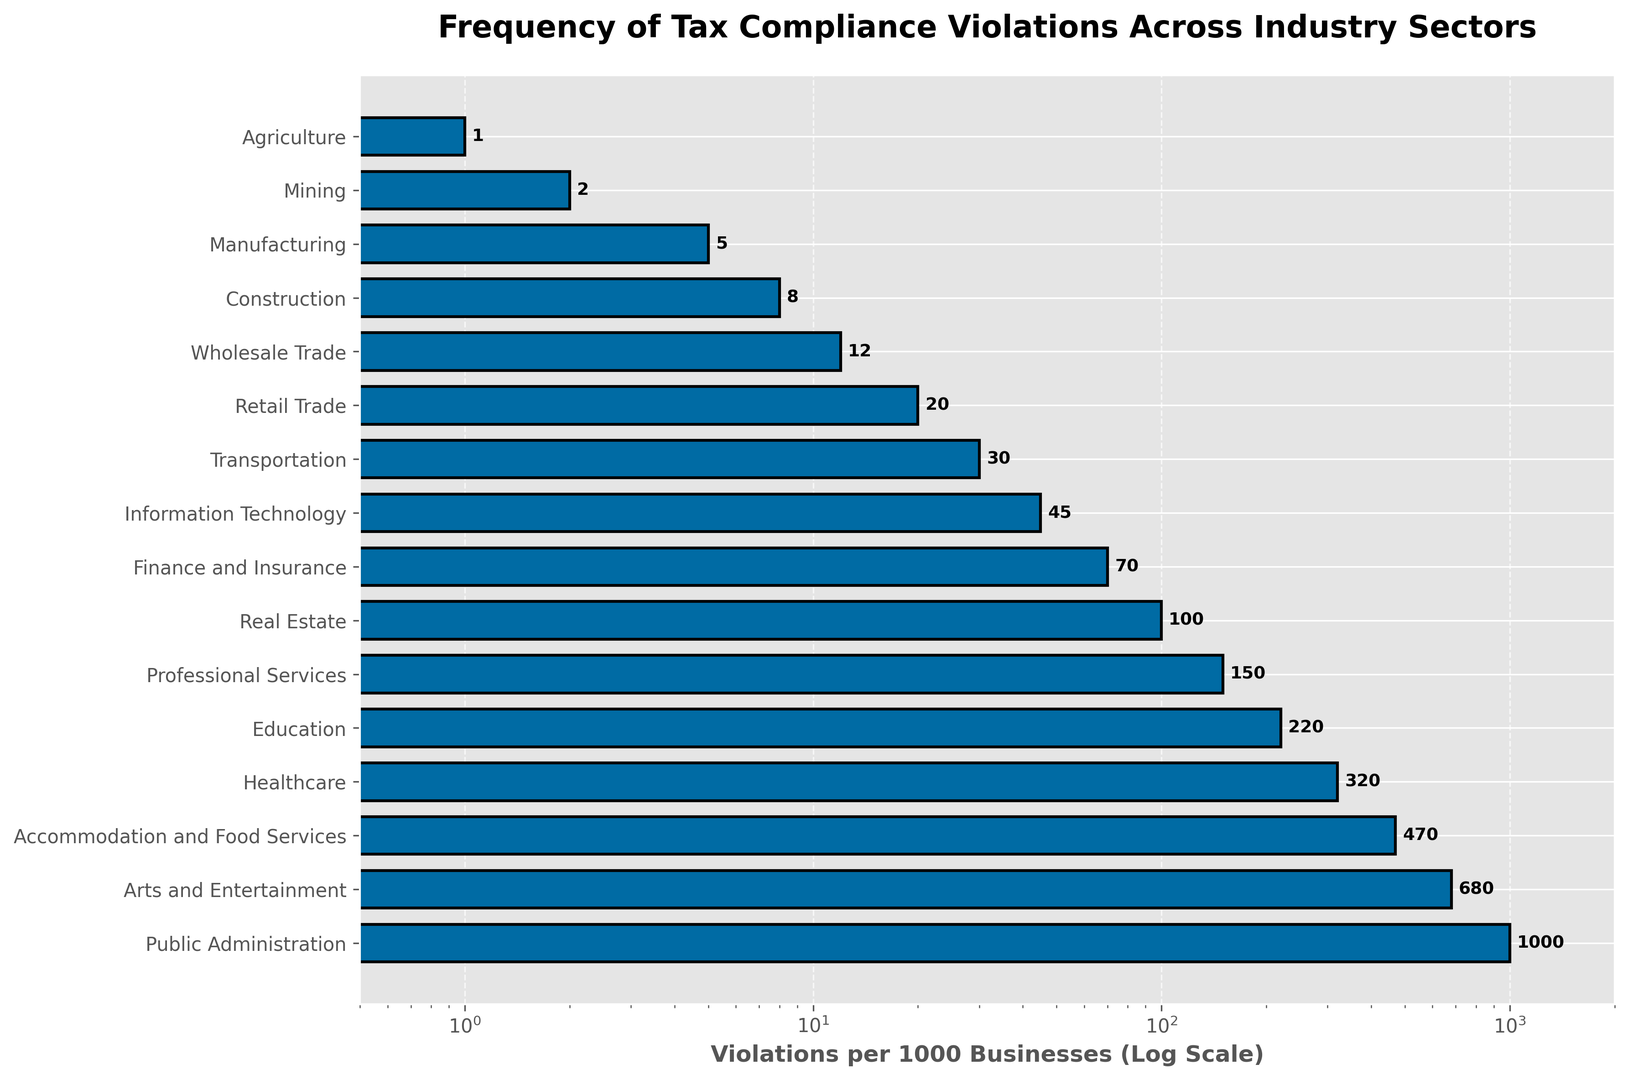Which industry sector has the highest frequency of tax compliance violations? By looking at the highest bar in the horizontal bar chart, which represents the value on the logarithmic scale, Public Administration has the highest frequency of tax compliance violations.
Answer: Public Administration Which industry sectors have fewer than 10 violations per 1000 businesses? By observing the bars that do not extend past the 10 mark on the log scale, the sectors with fewer than 10 violations per 1000 businesses are Agriculture, Mining, and Manufacturing.
Answer: Agriculture, Mining, Manufacturing What is the difference in the number of violations per 1000 businesses between the Healthcare sector and the Finance and Insurance sector? The violations for Healthcare are 320 and for Finance and Insurance are 70. The difference is 320 - 70.
Answer: 250 Which sector has more compliance violations, Mining or Accommodation and Food Services, and by how much? Mining has 2 violations and Accommodation and Food Services has 470. The difference is 470 - 2.
Answer: Accommodation and Food Services by 468 What is the ratio of violations per 1000 businesses between Education and Manufacturing sectors? Education has 220 violations and Manufacturing has 5. The ratio is calculated as 220 / 5.
Answer: 44 Between which two adjacent sectors is the largest jump in violations observed? By identifying the largest gap between two adjacent bars on the log scale, the largest jump is observed between Healthcare (320) and Accommodation and Food Services (470). The difference is 150.
Answer: Healthcare and Accommodation and Food Services On a log scale from 0.5 to 2000, what is the median value of violations per 1000 businesses across all sectors? To find the median, order the values and find the middle value: (1, 2, 5, 8, 12, 20, 30, 45, 70, 100, 150, 220, 320, 470, 680, 1000). The median is 57.5, the average of the 8th and 9th values (45 and 70).
Answer: 57.5 Which sector has approximately ten times more violations than the Professional Services sector? Professional Services have 150 violations. Checking the sector closest to ten times that number: 150 * 10 = 1500. But the closest sector we have in the data is Public Administration with 1000, which is less than 1500 but still proportional in a logarithmic sense.
Answer: Public Administration Which sector has the violations per 1000 businesses close to the average of Accommodation and Food Services and Real Estate sectors? The average of Accommodation and Food Services (470) and Real Estate (100) is (470 + 100) / 2 = 285. By comparing the numbers, the Healthcare sector with 320 violations is the closest to 285.
Answer: Healthcare Imagine it’s required to reduce the number of violations by 50% across all sectors. After the reduction, how many sectors will have fewer than 100 violations per 1000 businesses? Halving the figures: Agriculture (0.5), Mining (1), Manufacturing (2.5), Construction (4), Wholesale Trade (6), Retail Trade (10), Transportation (15), Information Technology (22.5), Finance and Insurance (35), Real Estate (50), Professional Services (75), Education (110), Healthcare (160), Accommodation and Food Services (235), Arts and Entertainment (340), Public Administration (500). Thus, sectors with fewer than 100 violations remain: Agriculture, Mining, Manufacturing, Construction, Wholesale Trade, Retail Trade, Transportation, Information Technology, Finance and Insurance, and Real Estate, totaling ten sectors.
Answer: 10 